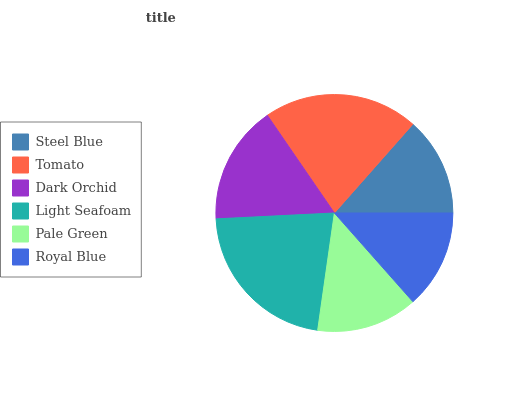Is Royal Blue the minimum?
Answer yes or no. Yes. Is Light Seafoam the maximum?
Answer yes or no. Yes. Is Tomato the minimum?
Answer yes or no. No. Is Tomato the maximum?
Answer yes or no. No. Is Tomato greater than Steel Blue?
Answer yes or no. Yes. Is Steel Blue less than Tomato?
Answer yes or no. Yes. Is Steel Blue greater than Tomato?
Answer yes or no. No. Is Tomato less than Steel Blue?
Answer yes or no. No. Is Dark Orchid the high median?
Answer yes or no. Yes. Is Pale Green the low median?
Answer yes or no. Yes. Is Steel Blue the high median?
Answer yes or no. No. Is Tomato the low median?
Answer yes or no. No. 